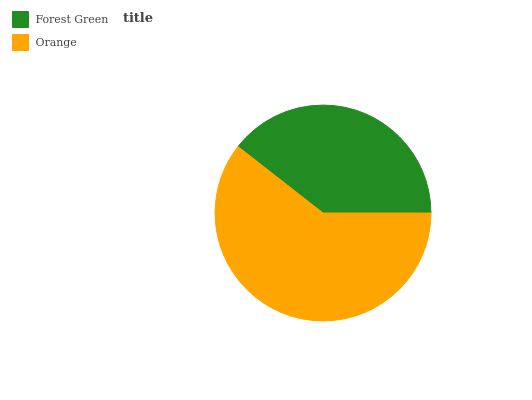Is Forest Green the minimum?
Answer yes or no. Yes. Is Orange the maximum?
Answer yes or no. Yes. Is Orange the minimum?
Answer yes or no. No. Is Orange greater than Forest Green?
Answer yes or no. Yes. Is Forest Green less than Orange?
Answer yes or no. Yes. Is Forest Green greater than Orange?
Answer yes or no. No. Is Orange less than Forest Green?
Answer yes or no. No. Is Orange the high median?
Answer yes or no. Yes. Is Forest Green the low median?
Answer yes or no. Yes. Is Forest Green the high median?
Answer yes or no. No. Is Orange the low median?
Answer yes or no. No. 